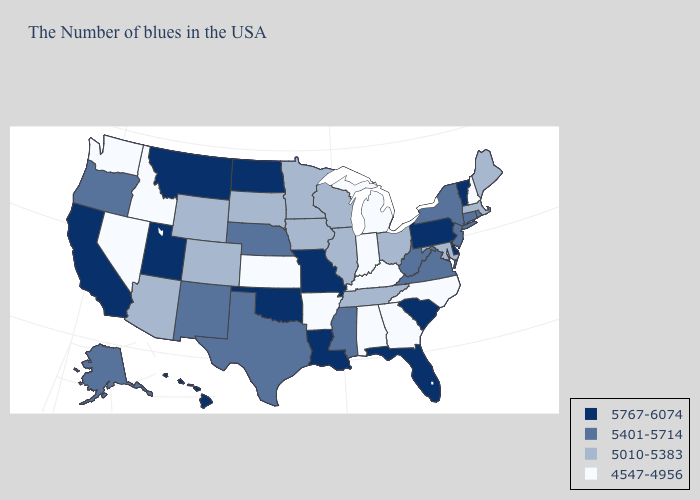Which states hav the highest value in the MidWest?
Give a very brief answer. Missouri, North Dakota. Which states have the highest value in the USA?
Keep it brief. Vermont, Delaware, Pennsylvania, South Carolina, Florida, Louisiana, Missouri, Oklahoma, North Dakota, Utah, Montana, California, Hawaii. Name the states that have a value in the range 5010-5383?
Concise answer only. Maine, Massachusetts, Maryland, Ohio, Tennessee, Wisconsin, Illinois, Minnesota, Iowa, South Dakota, Wyoming, Colorado, Arizona. Name the states that have a value in the range 5401-5714?
Concise answer only. Rhode Island, Connecticut, New York, New Jersey, Virginia, West Virginia, Mississippi, Nebraska, Texas, New Mexico, Oregon, Alaska. Does New Hampshire have the highest value in the Northeast?
Concise answer only. No. What is the value of Michigan?
Concise answer only. 4547-4956. Name the states that have a value in the range 5767-6074?
Be succinct. Vermont, Delaware, Pennsylvania, South Carolina, Florida, Louisiana, Missouri, Oklahoma, North Dakota, Utah, Montana, California, Hawaii. What is the highest value in the MidWest ?
Short answer required. 5767-6074. Does the map have missing data?
Quick response, please. No. Does New Hampshire have the lowest value in the Northeast?
Concise answer only. Yes. Which states have the lowest value in the USA?
Keep it brief. New Hampshire, North Carolina, Georgia, Michigan, Kentucky, Indiana, Alabama, Arkansas, Kansas, Idaho, Nevada, Washington. Does North Carolina have the lowest value in the USA?
Short answer required. Yes. Name the states that have a value in the range 5767-6074?
Be succinct. Vermont, Delaware, Pennsylvania, South Carolina, Florida, Louisiana, Missouri, Oklahoma, North Dakota, Utah, Montana, California, Hawaii. What is the value of Arkansas?
Write a very short answer. 4547-4956. Name the states that have a value in the range 5010-5383?
Answer briefly. Maine, Massachusetts, Maryland, Ohio, Tennessee, Wisconsin, Illinois, Minnesota, Iowa, South Dakota, Wyoming, Colorado, Arizona. 